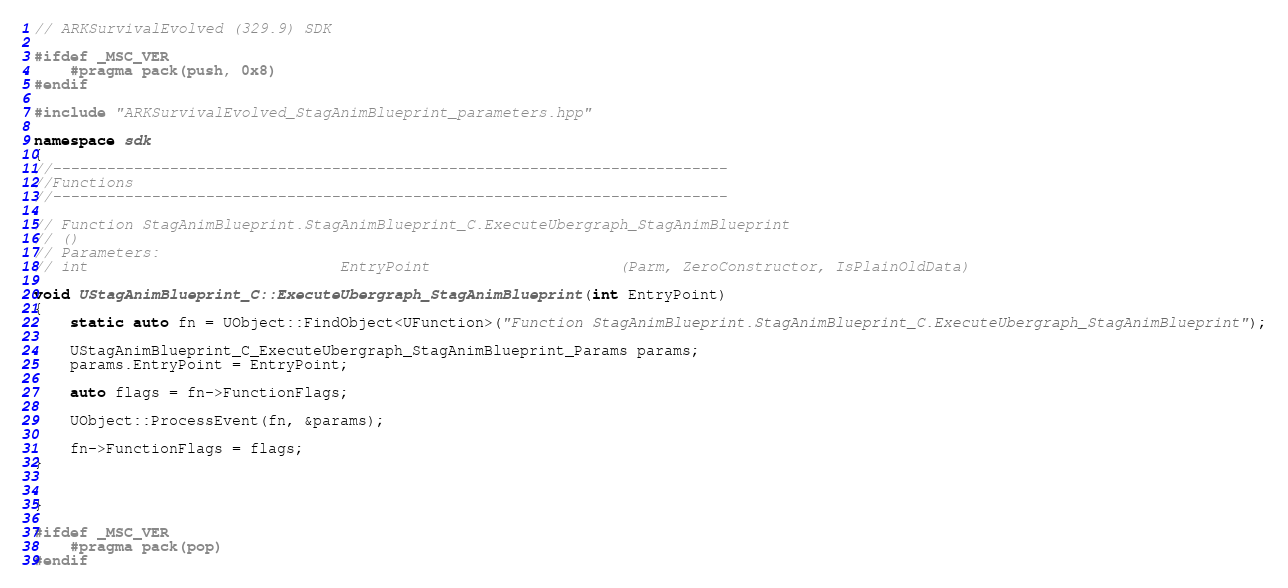<code> <loc_0><loc_0><loc_500><loc_500><_C++_>// ARKSurvivalEvolved (329.9) SDK

#ifdef _MSC_VER
	#pragma pack(push, 0x8)
#endif

#include "ARKSurvivalEvolved_StagAnimBlueprint_parameters.hpp"

namespace sdk
{
//---------------------------------------------------------------------------
//Functions
//---------------------------------------------------------------------------

// Function StagAnimBlueprint.StagAnimBlueprint_C.ExecuteUbergraph_StagAnimBlueprint
// ()
// Parameters:
// int                            EntryPoint                     (Parm, ZeroConstructor, IsPlainOldData)

void UStagAnimBlueprint_C::ExecuteUbergraph_StagAnimBlueprint(int EntryPoint)
{
	static auto fn = UObject::FindObject<UFunction>("Function StagAnimBlueprint.StagAnimBlueprint_C.ExecuteUbergraph_StagAnimBlueprint");

	UStagAnimBlueprint_C_ExecuteUbergraph_StagAnimBlueprint_Params params;
	params.EntryPoint = EntryPoint;

	auto flags = fn->FunctionFlags;

	UObject::ProcessEvent(fn, &params);

	fn->FunctionFlags = flags;
}


}

#ifdef _MSC_VER
	#pragma pack(pop)
#endif
</code> 